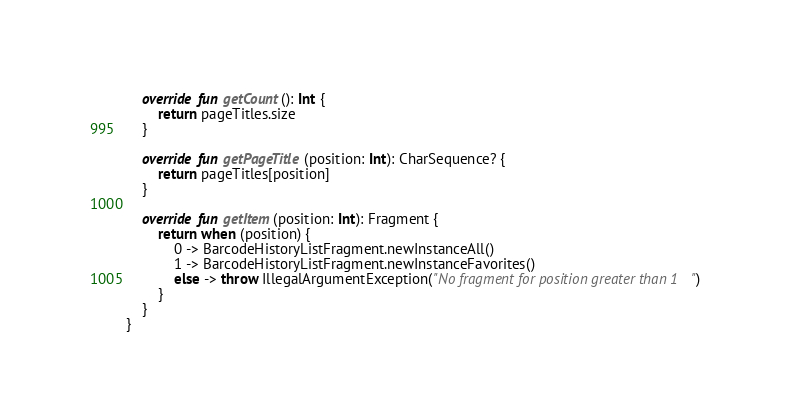<code> <loc_0><loc_0><loc_500><loc_500><_Kotlin_>    override fun getCount(): Int {
        return pageTitles.size
    }

    override fun getPageTitle(position: Int): CharSequence? {
        return pageTitles[position]
    }

    override fun getItem(position: Int): Fragment {
        return when (position) {
            0 -> BarcodeHistoryListFragment.newInstanceAll()
            1 -> BarcodeHistoryListFragment.newInstanceFavorites()
            else -> throw IllegalArgumentException("No fragment for position greater than 1")
        }
    }
}</code> 